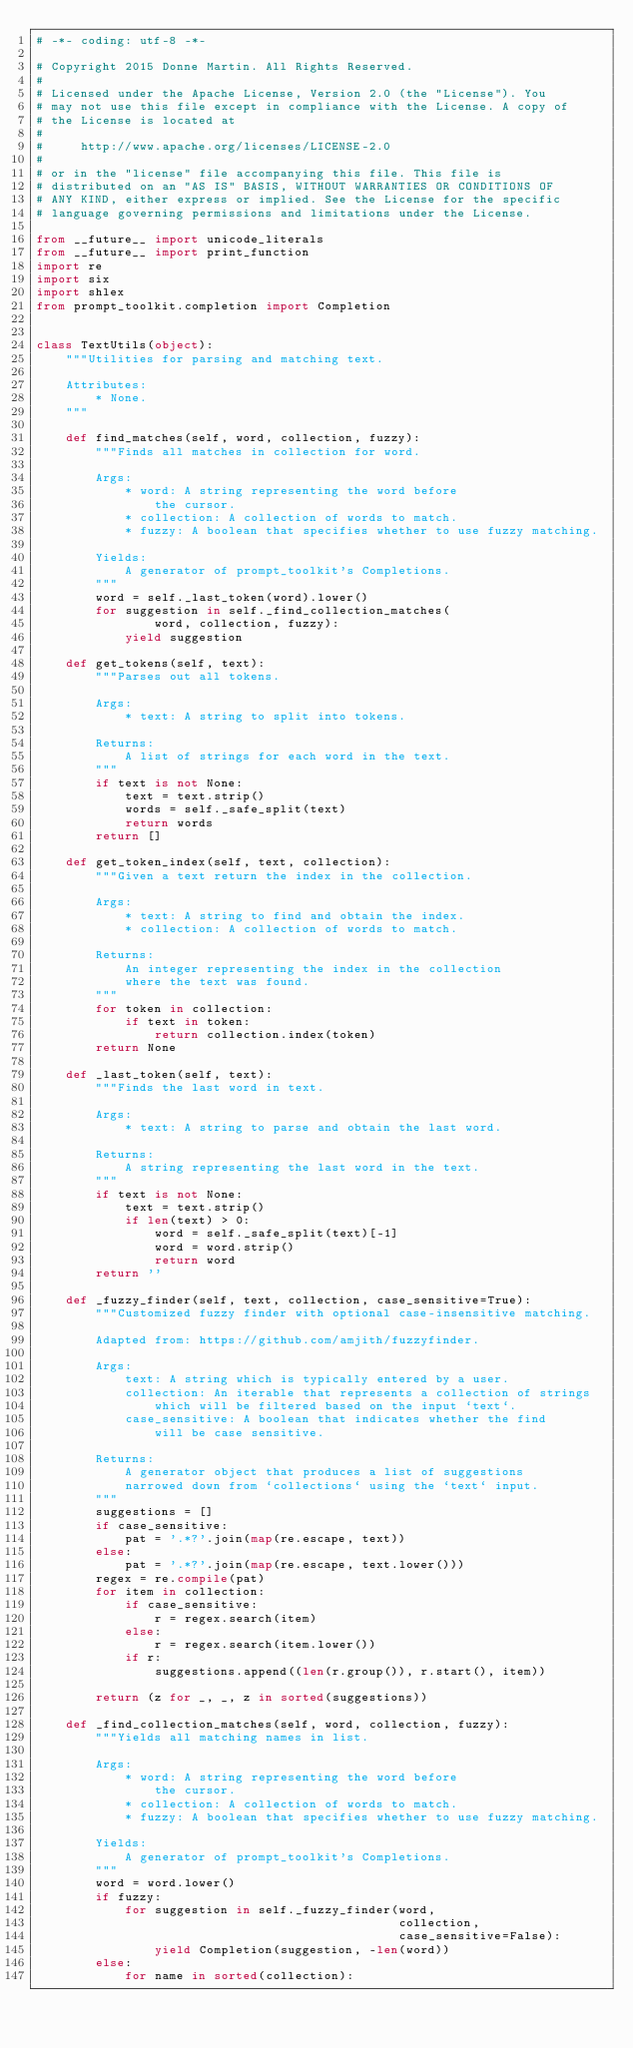Convert code to text. <code><loc_0><loc_0><loc_500><loc_500><_Python_># -*- coding: utf-8 -*-

# Copyright 2015 Donne Martin. All Rights Reserved.
#
# Licensed under the Apache License, Version 2.0 (the "License"). You
# may not use this file except in compliance with the License. A copy of
# the License is located at
#
#     http://www.apache.org/licenses/LICENSE-2.0
#
# or in the "license" file accompanying this file. This file is
# distributed on an "AS IS" BASIS, WITHOUT WARRANTIES OR CONDITIONS OF
# ANY KIND, either express or implied. See the License for the specific
# language governing permissions and limitations under the License.

from __future__ import unicode_literals
from __future__ import print_function
import re
import six
import shlex
from prompt_toolkit.completion import Completion


class TextUtils(object):
    """Utilities for parsing and matching text.

    Attributes:
        * None.
    """

    def find_matches(self, word, collection, fuzzy):
        """Finds all matches in collection for word.

        Args:
            * word: A string representing the word before
                the cursor.
            * collection: A collection of words to match.
            * fuzzy: A boolean that specifies whether to use fuzzy matching.

        Yields:
            A generator of prompt_toolkit's Completions.
        """
        word = self._last_token(word).lower()
        for suggestion in self._find_collection_matches(
                word, collection, fuzzy):
            yield suggestion

    def get_tokens(self, text):
        """Parses out all tokens.

        Args:
            * text: A string to split into tokens.

        Returns:
            A list of strings for each word in the text.
        """
        if text is not None:
            text = text.strip()
            words = self._safe_split(text)
            return words
        return []

    def get_token_index(self, text, collection):
        """Given a text return the index in the collection.

        Args:
            * text: A string to find and obtain the index.
            * collection: A collection of words to match.

        Returns:
            An integer representing the index in the collection
            where the text was found.
        """
        for token in collection:
            if text in token:
                return collection.index(token)
        return None

    def _last_token(self, text):
        """Finds the last word in text.

        Args:
            * text: A string to parse and obtain the last word.

        Returns:
            A string representing the last word in the text.
        """
        if text is not None:
            text = text.strip()
            if len(text) > 0:
                word = self._safe_split(text)[-1]
                word = word.strip()
                return word
        return ''

    def _fuzzy_finder(self, text, collection, case_sensitive=True):
        """Customized fuzzy finder with optional case-insensitive matching.

        Adapted from: https://github.com/amjith/fuzzyfinder.

        Args:
            text: A string which is typically entered by a user.
            collection: An iterable that represents a collection of strings
                which will be filtered based on the input `text`.
            case_sensitive: A boolean that indicates whether the find
                will be case sensitive.

        Returns:
            A generator object that produces a list of suggestions
            narrowed down from `collections` using the `text` input.
        """
        suggestions = []
        if case_sensitive:
            pat = '.*?'.join(map(re.escape, text))
        else:
            pat = '.*?'.join(map(re.escape, text.lower()))
        regex = re.compile(pat)
        for item in collection:
            if case_sensitive:
                r = regex.search(item)
            else:
                r = regex.search(item.lower())
            if r:
                suggestions.append((len(r.group()), r.start(), item))

        return (z for _, _, z in sorted(suggestions))

    def _find_collection_matches(self, word, collection, fuzzy):
        """Yields all matching names in list.

        Args:
            * word: A string representing the word before
                the cursor.
            * collection: A collection of words to match.
            * fuzzy: A boolean that specifies whether to use fuzzy matching.

        Yields:
            A generator of prompt_toolkit's Completions.
        """
        word = word.lower()
        if fuzzy:
            for suggestion in self._fuzzy_finder(word,
                                                 collection,
                                                 case_sensitive=False):
                yield Completion(suggestion, -len(word))
        else:
            for name in sorted(collection):</code> 